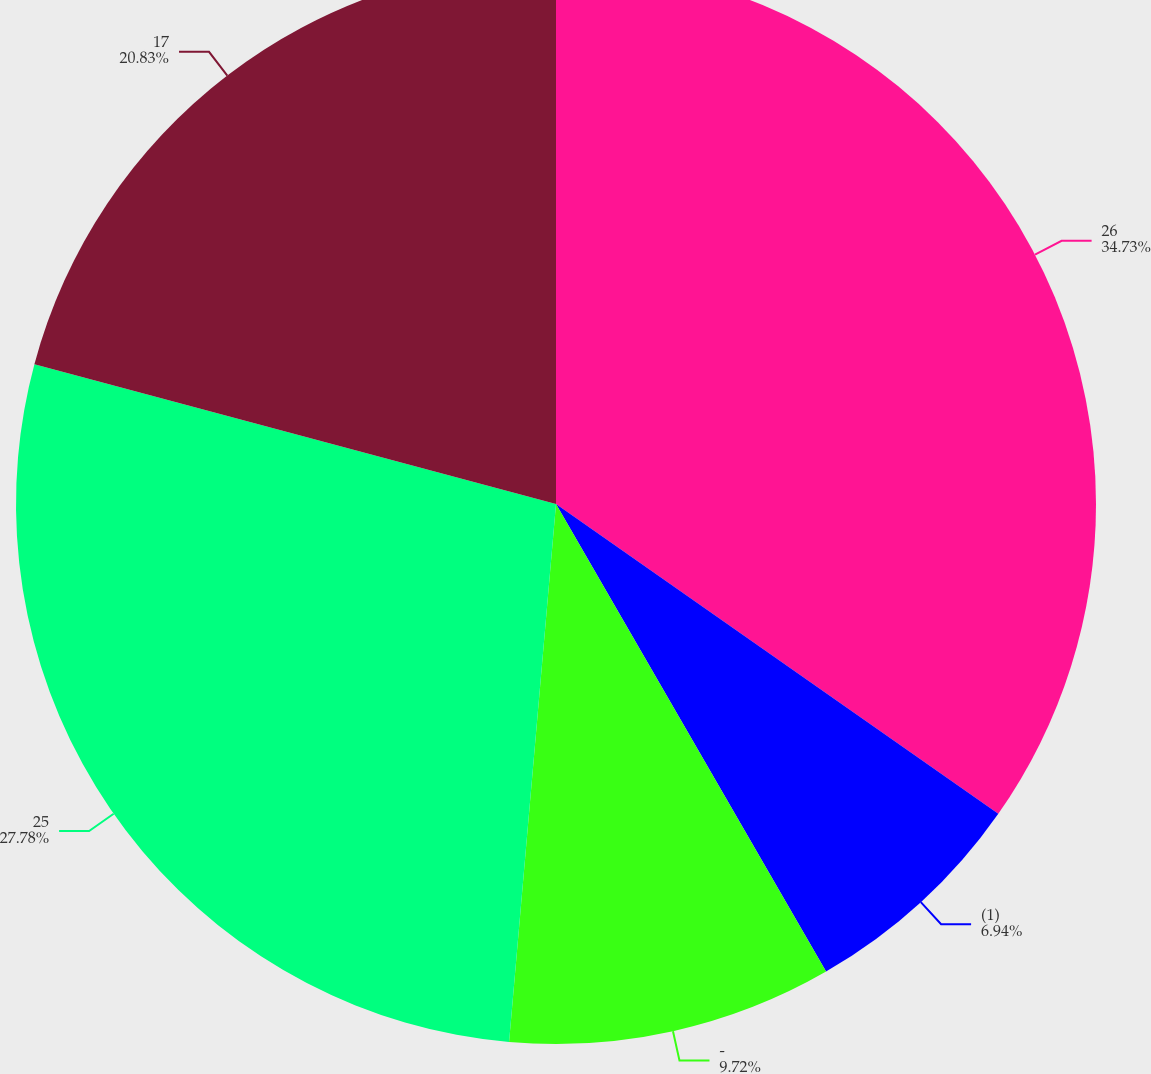<chart> <loc_0><loc_0><loc_500><loc_500><pie_chart><fcel>26<fcel>(1)<fcel>-<fcel>25<fcel>17<nl><fcel>34.72%<fcel>6.94%<fcel>9.72%<fcel>27.78%<fcel>20.83%<nl></chart> 